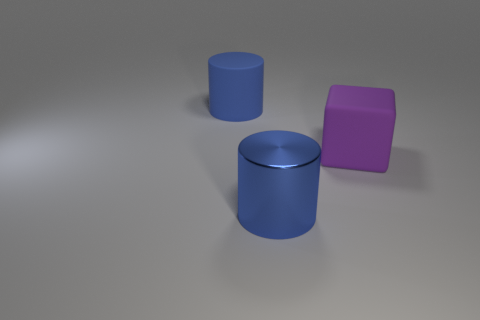How many other things are there of the same shape as the metallic object?
Ensure brevity in your answer.  1. Do the big purple rubber thing and the large blue object in front of the purple block have the same shape?
Your answer should be very brief. No. There is a matte cube; how many big objects are to the right of it?
Provide a succinct answer. 0. Do the rubber thing in front of the blue matte object and the metal thing have the same shape?
Offer a terse response. No. What color is the rubber thing to the right of the large metallic object?
Your answer should be very brief. Purple. What shape is the large object that is made of the same material as the large purple cube?
Keep it short and to the point. Cylinder. Are there any other things that have the same color as the block?
Offer a terse response. No. Are there more cubes left of the big purple rubber object than big purple blocks that are right of the large blue rubber cylinder?
Provide a succinct answer. No. How many blue shiny cylinders are the same size as the purple matte cube?
Offer a terse response. 1. Is the number of big rubber cylinders to the right of the blue matte cylinder less than the number of large metal things in front of the big purple block?
Your response must be concise. Yes. 